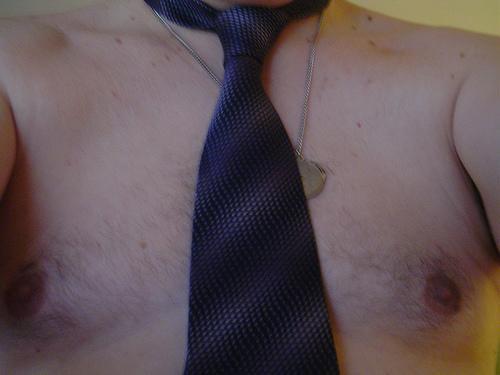How many bike on this image?
Give a very brief answer. 0. 